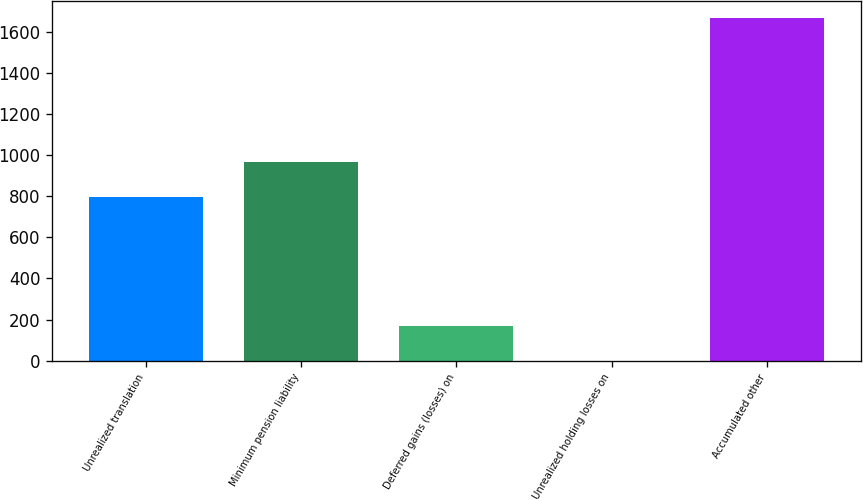<chart> <loc_0><loc_0><loc_500><loc_500><bar_chart><fcel>Unrealized translation<fcel>Minimum pension liability<fcel>Deferred gains (losses) on<fcel>Unrealized holding losses on<fcel>Accumulated other<nl><fcel>797.9<fcel>964.83<fcel>167.03<fcel>0.1<fcel>1669.4<nl></chart> 